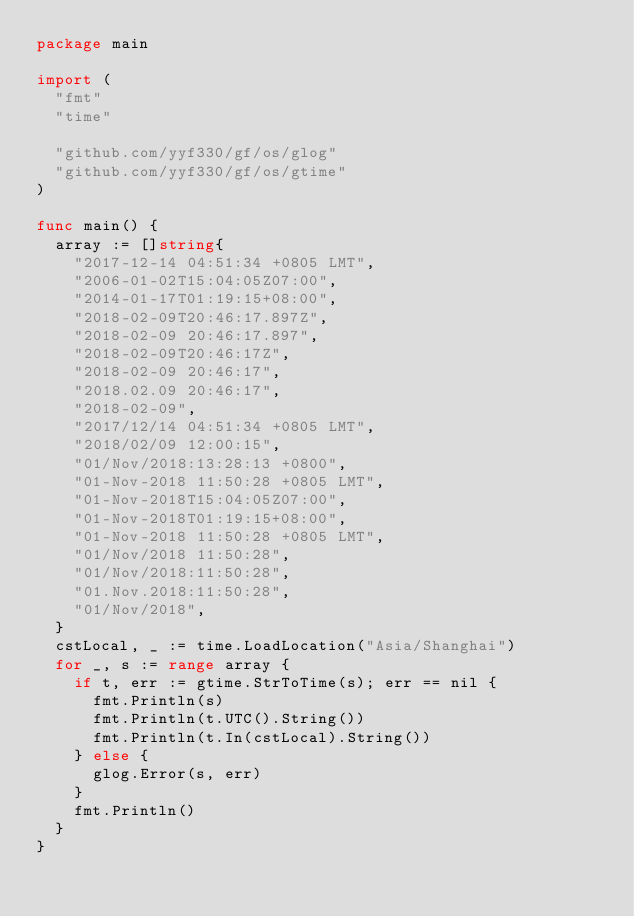<code> <loc_0><loc_0><loc_500><loc_500><_Go_>package main

import (
	"fmt"
	"time"

	"github.com/yyf330/gf/os/glog"
	"github.com/yyf330/gf/os/gtime"
)

func main() {
	array := []string{
		"2017-12-14 04:51:34 +0805 LMT",
		"2006-01-02T15:04:05Z07:00",
		"2014-01-17T01:19:15+08:00",
		"2018-02-09T20:46:17.897Z",
		"2018-02-09 20:46:17.897",
		"2018-02-09T20:46:17Z",
		"2018-02-09 20:46:17",
		"2018.02.09 20:46:17",
		"2018-02-09",
		"2017/12/14 04:51:34 +0805 LMT",
		"2018/02/09 12:00:15",
		"01/Nov/2018:13:28:13 +0800",
		"01-Nov-2018 11:50:28 +0805 LMT",
		"01-Nov-2018T15:04:05Z07:00",
		"01-Nov-2018T01:19:15+08:00",
		"01-Nov-2018 11:50:28 +0805 LMT",
		"01/Nov/2018 11:50:28",
		"01/Nov/2018:11:50:28",
		"01.Nov.2018:11:50:28",
		"01/Nov/2018",
	}
	cstLocal, _ := time.LoadLocation("Asia/Shanghai")
	for _, s := range array {
		if t, err := gtime.StrToTime(s); err == nil {
			fmt.Println(s)
			fmt.Println(t.UTC().String())
			fmt.Println(t.In(cstLocal).String())
		} else {
			glog.Error(s, err)
		}
		fmt.Println()
	}
}
</code> 